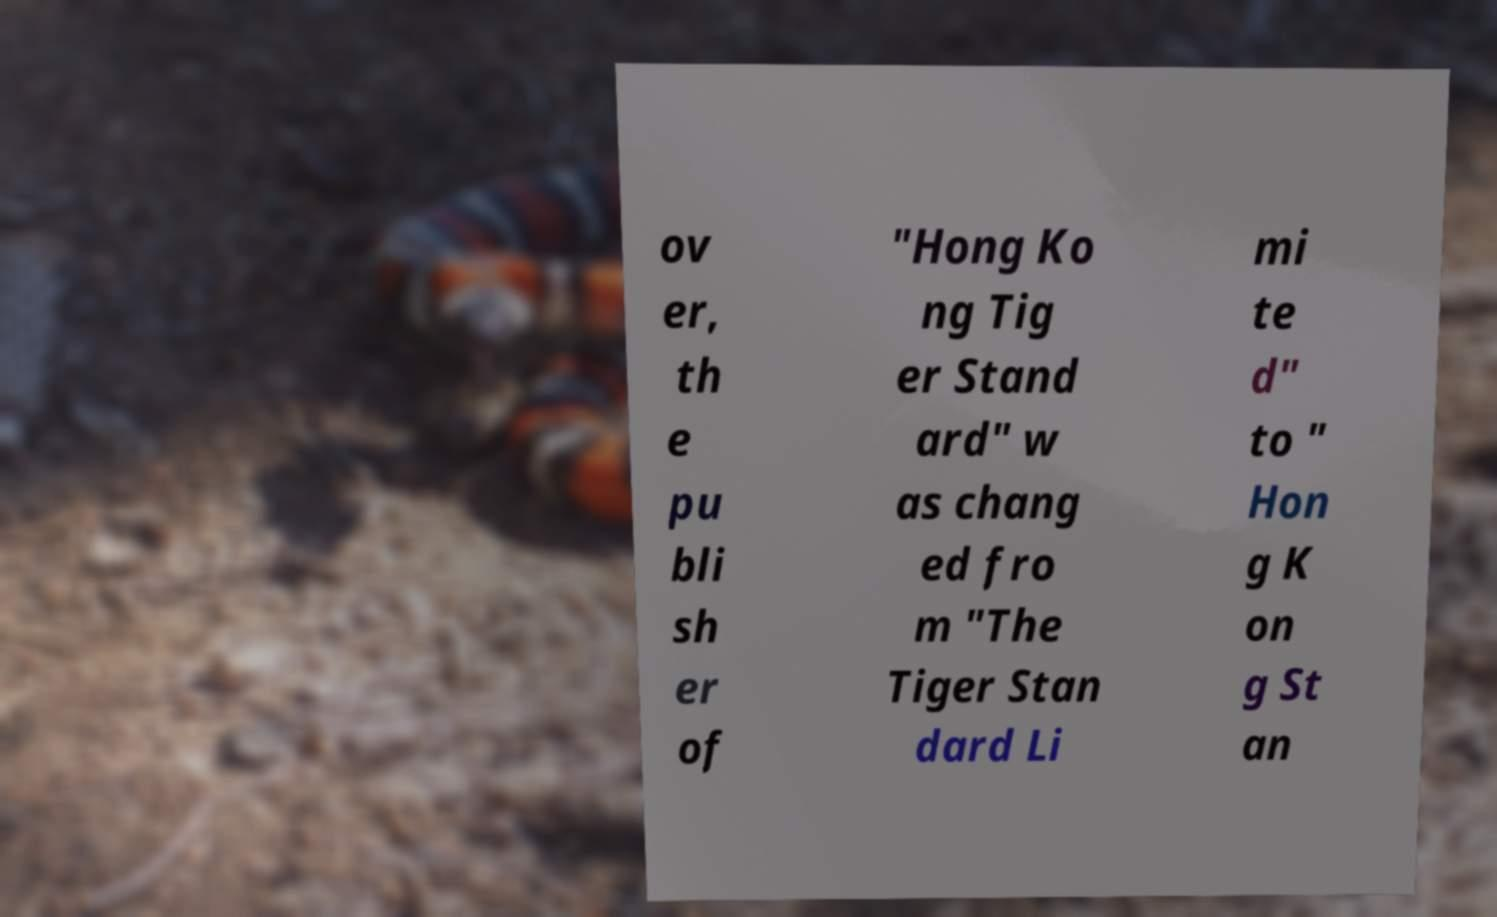Please read and relay the text visible in this image. What does it say? ov er, th e pu bli sh er of "Hong Ko ng Tig er Stand ard" w as chang ed fro m "The Tiger Stan dard Li mi te d" to " Hon g K on g St an 